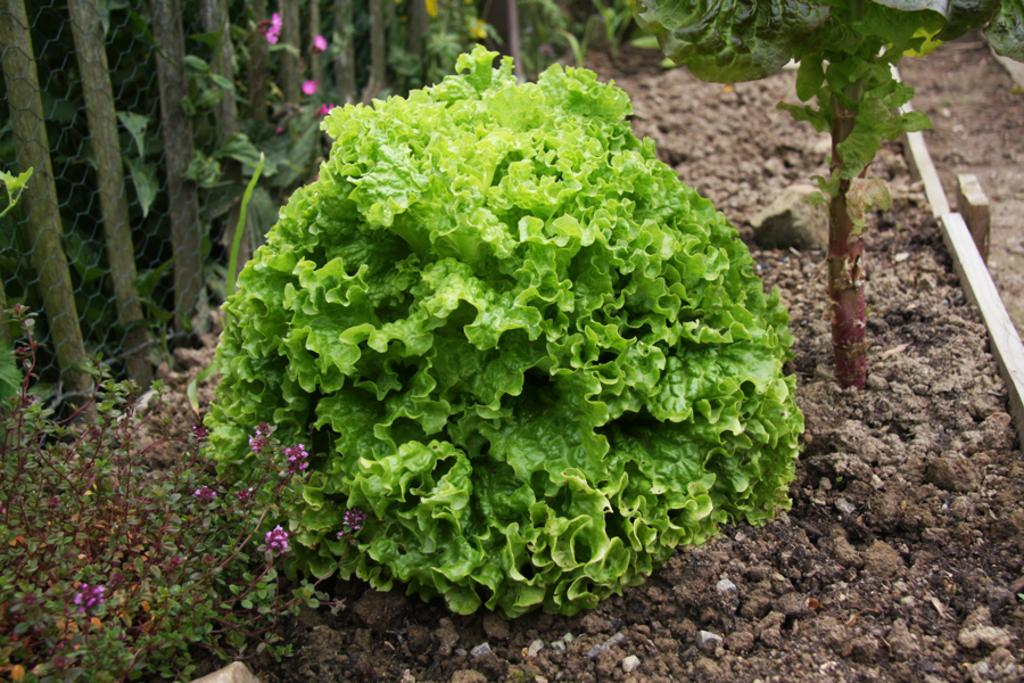What is located in the front of the image? There is a plant in the front of the image. What can be seen in the background of the image? There is a fence and plants in the background of the image. What is on the ground in the image? There are stones on the ground in the image. How many letters are visible on the plant in the image? There are no letters visible on the plant in the image. Are there any children playing near the fence in the image? There is no mention of children in the image, so we cannot determine if they are present or not. 